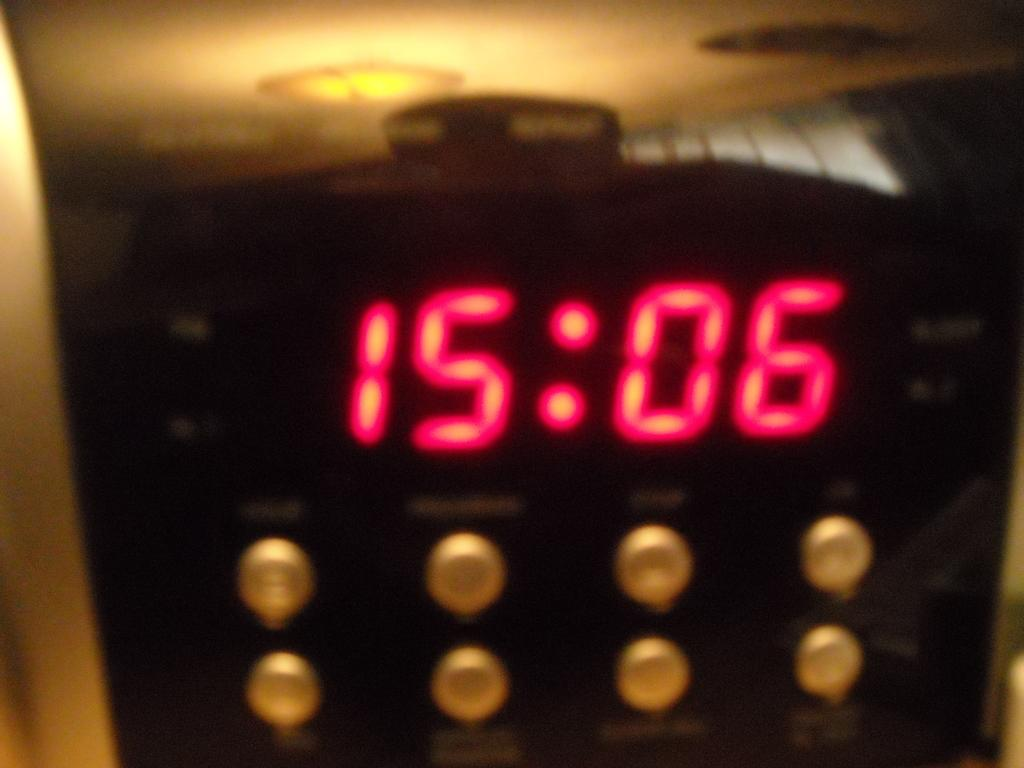Provide a one-sentence caption for the provided image. An electronic box with the digits 15:06 displayed in red. 